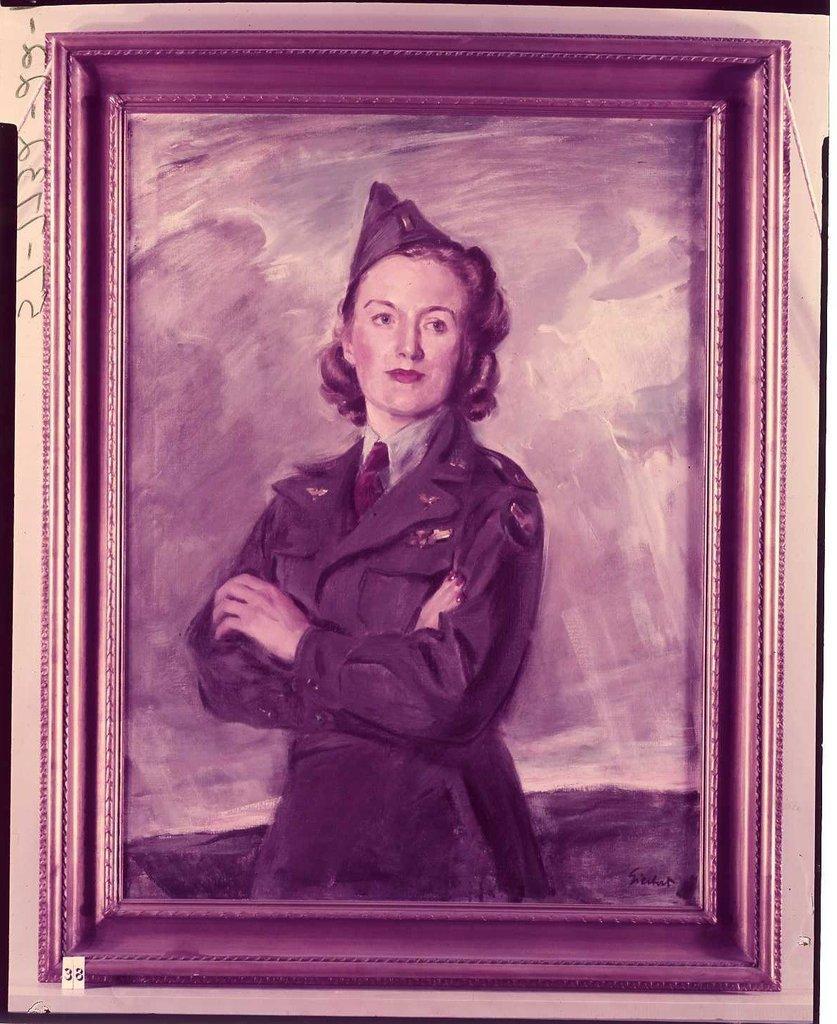Can you describe this image briefly? In this image, we can see a painting with frame. In this painting, we can see a woman. Left side of the image, we can see some text. At the bottom, there is a tag we can see. 